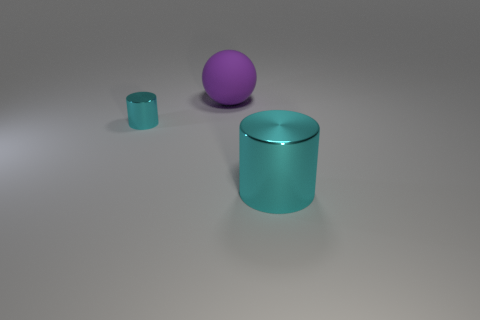What can be inferred about the lighting in the scene based on the shadows? The shadows in the scene suggest a light source coming from the upper left side, casting shadows diagonally to the right which slightly elongate the objects on the ground, indicating that the light could be at a moderate height and angle. Does the lighting affect the perceived colors of the objects? Yes, the lighting can influence the perceived colors, making them appear lighter or darker and affecting their intensity. The reflected light can also add highlights to the objects, particularly noticeable on the reflective surfaces of the cyan cylinders. 